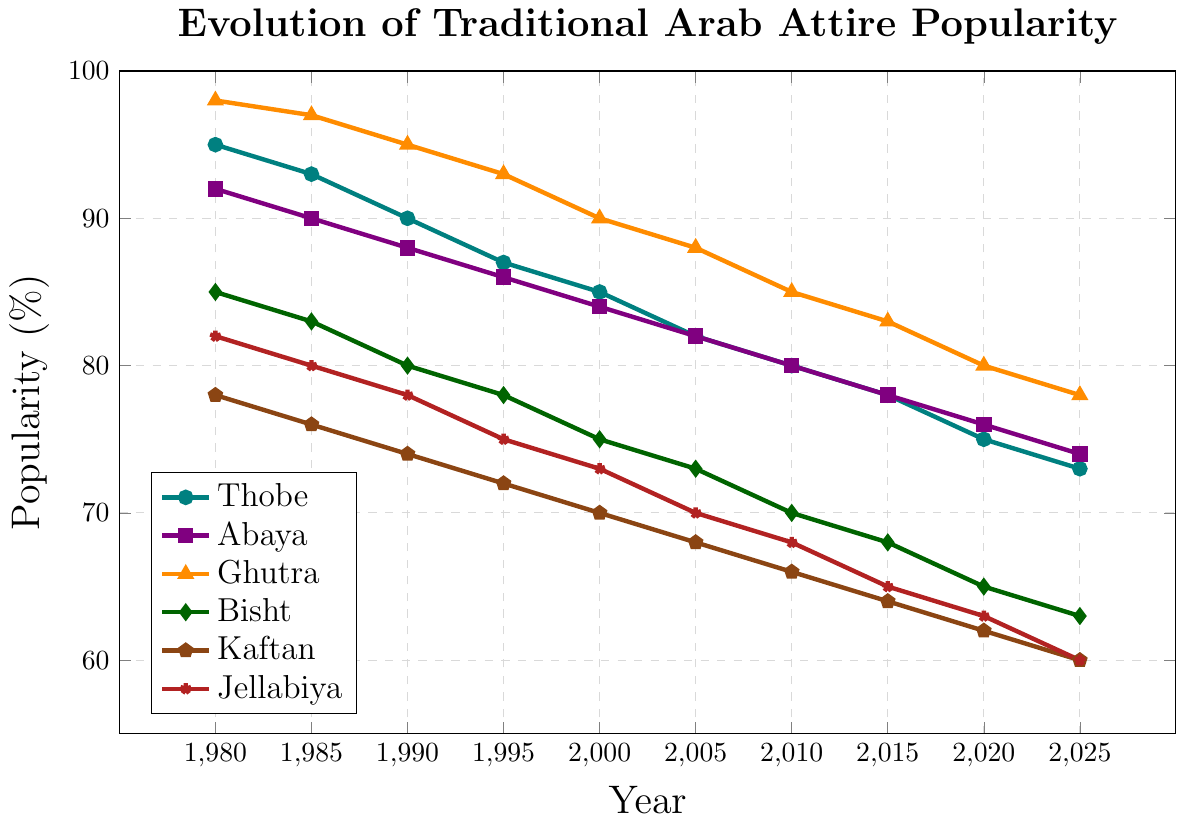Which garment type had the highest popularity in 1980? The figure shows popularity over time segmented by garment type. In 1980, the Ghutra had the highest popularity percentage at 98% compared to other garments.
Answer: Ghutra How much did the popularity of the Thobe change from 1980 to 2025? To find the change in popularity of the Thobe, subtract its popularity in 2025 (73%) from its popularity in 1980 (95%). The change is 95% - 73% = 22%.
Answer: 22% Which two garment types have the closest popularity rates in 2025? Checking the 2025 data points, the Abaya (74%) and Thobe (73%) have the closest popularity rates among the listed garments.
Answer: Thobe and Abaya What is the average popularity of the Jellabiya from 1980 to 2025? Calculate the average by adding the popularity percentages of Jellabiya from 1980 to 2025 and dividing by the number of years: (82+80+78+75+73+70+68+65+63+60)/10 = 71.4%
Answer: 71.4% Which garment type has shown the most consistent decline in popularity over the years? By visually inspecting the declining trends, all garment types show a decline but the Kaftan has a steady and consistent decrease from 78% in 1980 to 60% in 2025, with no deviations.
Answer: Kaftan Between 2000 and 2025, which garment experienced the largest decrease in popularity? By subtracting the popularity values of each garment in 2025 from those in 2000, the Thobe decreased from 85% to 73%, which is 12%, the largest decrease among all garments listed.
Answer: Thobe In which year did the Abaya and Thobe have the same popularity percentage? According to the chart, the Abaya and Thobe both had popularity percentages of 80% in the year 2010.
Answer: 2010 How does the popularity of the Bisht in 2025 compare to its popularity in 1980? The Bisht had a popularity of 85% in 1980 and 63% in 2025. The comparison shows that it has decreased by 22%.
Answer: Decreased by 22% Which garment type had a popularity value closest to the median popularity of all garments in 1980? For 1980, the sorted values are 78, 82, 85, 92, 95, 98. The median values are (85+92)/2 = 88.5. The Abaya at 92% is the closest to 88.5.
Answer: Abaya 